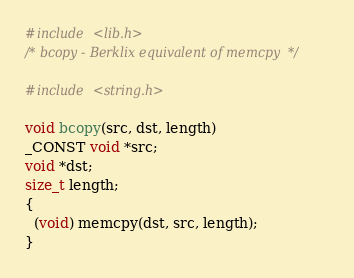<code> <loc_0><loc_0><loc_500><loc_500><_C_>#include <lib.h>
/* bcopy - Berklix equivalent of memcpy  */

#include <string.h>

void bcopy(src, dst, length)
_CONST void *src;
void *dst;
size_t length;
{
  (void) memcpy(dst, src, length);
}
</code> 